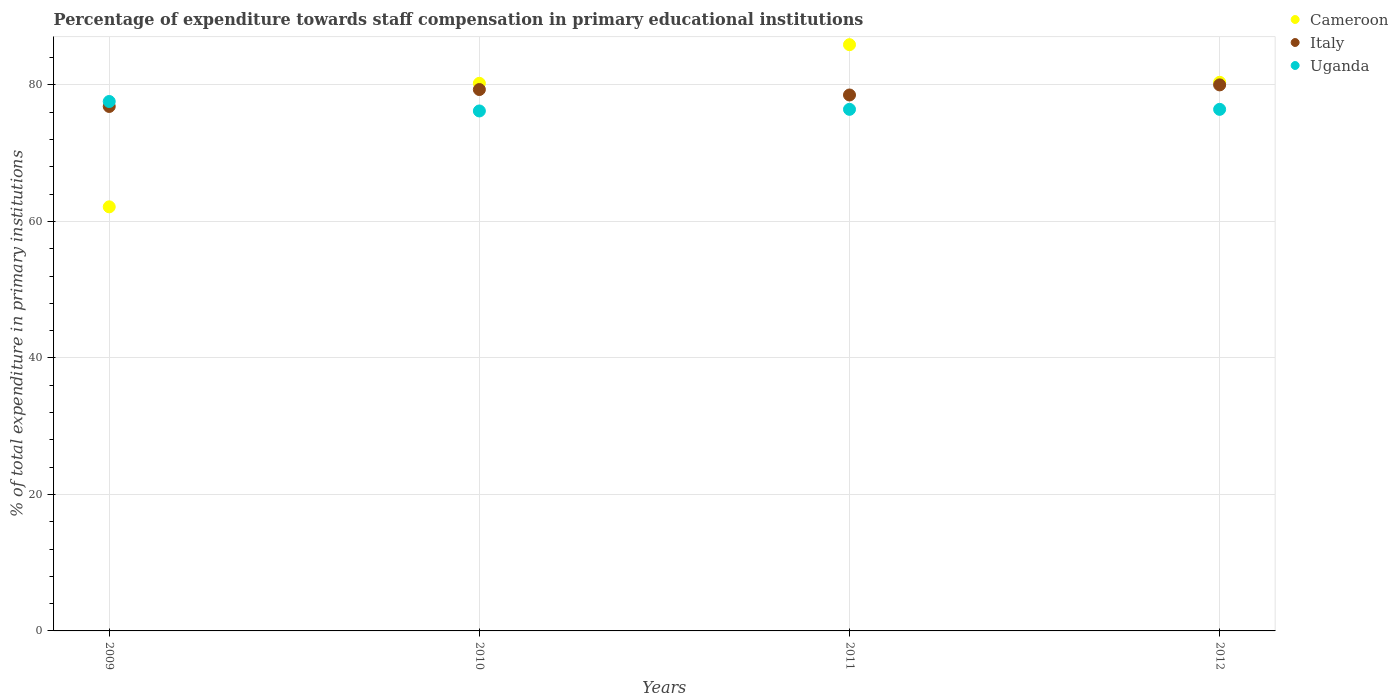How many different coloured dotlines are there?
Provide a succinct answer. 3. What is the percentage of expenditure towards staff compensation in Cameroon in 2012?
Your response must be concise. 80.4. Across all years, what is the maximum percentage of expenditure towards staff compensation in Italy?
Make the answer very short. 80.01. Across all years, what is the minimum percentage of expenditure towards staff compensation in Cameroon?
Offer a very short reply. 62.15. What is the total percentage of expenditure towards staff compensation in Cameroon in the graph?
Make the answer very short. 308.69. What is the difference between the percentage of expenditure towards staff compensation in Uganda in 2009 and that in 2011?
Offer a terse response. 1.15. What is the difference between the percentage of expenditure towards staff compensation in Uganda in 2011 and the percentage of expenditure towards staff compensation in Cameroon in 2012?
Provide a short and direct response. -3.96. What is the average percentage of expenditure towards staff compensation in Cameroon per year?
Offer a very short reply. 77.17. In the year 2010, what is the difference between the percentage of expenditure towards staff compensation in Cameroon and percentage of expenditure towards staff compensation in Uganda?
Provide a short and direct response. 4.05. What is the ratio of the percentage of expenditure towards staff compensation in Uganda in 2010 to that in 2011?
Give a very brief answer. 1. Is the difference between the percentage of expenditure towards staff compensation in Cameroon in 2009 and 2011 greater than the difference between the percentage of expenditure towards staff compensation in Uganda in 2009 and 2011?
Provide a succinct answer. No. What is the difference between the highest and the second highest percentage of expenditure towards staff compensation in Cameroon?
Make the answer very short. 5.51. What is the difference between the highest and the lowest percentage of expenditure towards staff compensation in Cameroon?
Offer a very short reply. 23.76. In how many years, is the percentage of expenditure towards staff compensation in Cameroon greater than the average percentage of expenditure towards staff compensation in Cameroon taken over all years?
Provide a succinct answer. 3. Is it the case that in every year, the sum of the percentage of expenditure towards staff compensation in Cameroon and percentage of expenditure towards staff compensation in Italy  is greater than the percentage of expenditure towards staff compensation in Uganda?
Offer a terse response. Yes. Does the percentage of expenditure towards staff compensation in Cameroon monotonically increase over the years?
Make the answer very short. No. Is the percentage of expenditure towards staff compensation in Uganda strictly greater than the percentage of expenditure towards staff compensation in Italy over the years?
Ensure brevity in your answer.  No. How many dotlines are there?
Offer a very short reply. 3. How many years are there in the graph?
Offer a very short reply. 4. What is the difference between two consecutive major ticks on the Y-axis?
Your answer should be compact. 20. Are the values on the major ticks of Y-axis written in scientific E-notation?
Your answer should be very brief. No. Does the graph contain grids?
Make the answer very short. Yes. Where does the legend appear in the graph?
Your response must be concise. Top right. How many legend labels are there?
Provide a short and direct response. 3. What is the title of the graph?
Your answer should be very brief. Percentage of expenditure towards staff compensation in primary educational institutions. What is the label or title of the X-axis?
Make the answer very short. Years. What is the label or title of the Y-axis?
Your response must be concise. % of total expenditure in primary institutions. What is the % of total expenditure in primary institutions of Cameroon in 2009?
Offer a very short reply. 62.15. What is the % of total expenditure in primary institutions in Italy in 2009?
Ensure brevity in your answer.  76.86. What is the % of total expenditure in primary institutions of Uganda in 2009?
Keep it short and to the point. 77.58. What is the % of total expenditure in primary institutions of Cameroon in 2010?
Make the answer very short. 80.25. What is the % of total expenditure in primary institutions in Italy in 2010?
Give a very brief answer. 79.33. What is the % of total expenditure in primary institutions of Uganda in 2010?
Your answer should be compact. 76.2. What is the % of total expenditure in primary institutions of Cameroon in 2011?
Keep it short and to the point. 85.91. What is the % of total expenditure in primary institutions in Italy in 2011?
Ensure brevity in your answer.  78.54. What is the % of total expenditure in primary institutions in Uganda in 2011?
Offer a terse response. 76.43. What is the % of total expenditure in primary institutions of Cameroon in 2012?
Provide a short and direct response. 80.4. What is the % of total expenditure in primary institutions of Italy in 2012?
Make the answer very short. 80.01. What is the % of total expenditure in primary institutions of Uganda in 2012?
Your response must be concise. 76.43. Across all years, what is the maximum % of total expenditure in primary institutions of Cameroon?
Offer a very short reply. 85.91. Across all years, what is the maximum % of total expenditure in primary institutions in Italy?
Your response must be concise. 80.01. Across all years, what is the maximum % of total expenditure in primary institutions in Uganda?
Offer a very short reply. 77.58. Across all years, what is the minimum % of total expenditure in primary institutions of Cameroon?
Provide a succinct answer. 62.15. Across all years, what is the minimum % of total expenditure in primary institutions in Italy?
Provide a succinct answer. 76.86. Across all years, what is the minimum % of total expenditure in primary institutions of Uganda?
Offer a terse response. 76.2. What is the total % of total expenditure in primary institutions in Cameroon in the graph?
Keep it short and to the point. 308.69. What is the total % of total expenditure in primary institutions in Italy in the graph?
Make the answer very short. 314.74. What is the total % of total expenditure in primary institutions in Uganda in the graph?
Make the answer very short. 306.64. What is the difference between the % of total expenditure in primary institutions in Cameroon in 2009 and that in 2010?
Your answer should be compact. -18.1. What is the difference between the % of total expenditure in primary institutions in Italy in 2009 and that in 2010?
Keep it short and to the point. -2.48. What is the difference between the % of total expenditure in primary institutions in Uganda in 2009 and that in 2010?
Your answer should be very brief. 1.39. What is the difference between the % of total expenditure in primary institutions in Cameroon in 2009 and that in 2011?
Give a very brief answer. -23.76. What is the difference between the % of total expenditure in primary institutions in Italy in 2009 and that in 2011?
Make the answer very short. -1.68. What is the difference between the % of total expenditure in primary institutions of Uganda in 2009 and that in 2011?
Your response must be concise. 1.15. What is the difference between the % of total expenditure in primary institutions in Cameroon in 2009 and that in 2012?
Offer a very short reply. -18.25. What is the difference between the % of total expenditure in primary institutions of Italy in 2009 and that in 2012?
Offer a very short reply. -3.16. What is the difference between the % of total expenditure in primary institutions in Uganda in 2009 and that in 2012?
Your response must be concise. 1.15. What is the difference between the % of total expenditure in primary institutions of Cameroon in 2010 and that in 2011?
Keep it short and to the point. -5.66. What is the difference between the % of total expenditure in primary institutions of Italy in 2010 and that in 2011?
Offer a terse response. 0.8. What is the difference between the % of total expenditure in primary institutions of Uganda in 2010 and that in 2011?
Your answer should be compact. -0.24. What is the difference between the % of total expenditure in primary institutions of Cameroon in 2010 and that in 2012?
Offer a very short reply. -0.15. What is the difference between the % of total expenditure in primary institutions in Italy in 2010 and that in 2012?
Make the answer very short. -0.68. What is the difference between the % of total expenditure in primary institutions of Uganda in 2010 and that in 2012?
Your answer should be very brief. -0.23. What is the difference between the % of total expenditure in primary institutions in Cameroon in 2011 and that in 2012?
Offer a terse response. 5.51. What is the difference between the % of total expenditure in primary institutions of Italy in 2011 and that in 2012?
Offer a terse response. -1.48. What is the difference between the % of total expenditure in primary institutions in Uganda in 2011 and that in 2012?
Provide a succinct answer. 0. What is the difference between the % of total expenditure in primary institutions of Cameroon in 2009 and the % of total expenditure in primary institutions of Italy in 2010?
Make the answer very short. -17.19. What is the difference between the % of total expenditure in primary institutions of Cameroon in 2009 and the % of total expenditure in primary institutions of Uganda in 2010?
Provide a succinct answer. -14.05. What is the difference between the % of total expenditure in primary institutions of Italy in 2009 and the % of total expenditure in primary institutions of Uganda in 2010?
Ensure brevity in your answer.  0.66. What is the difference between the % of total expenditure in primary institutions of Cameroon in 2009 and the % of total expenditure in primary institutions of Italy in 2011?
Keep it short and to the point. -16.39. What is the difference between the % of total expenditure in primary institutions of Cameroon in 2009 and the % of total expenditure in primary institutions of Uganda in 2011?
Give a very brief answer. -14.29. What is the difference between the % of total expenditure in primary institutions of Italy in 2009 and the % of total expenditure in primary institutions of Uganda in 2011?
Keep it short and to the point. 0.42. What is the difference between the % of total expenditure in primary institutions in Cameroon in 2009 and the % of total expenditure in primary institutions in Italy in 2012?
Provide a short and direct response. -17.87. What is the difference between the % of total expenditure in primary institutions in Cameroon in 2009 and the % of total expenditure in primary institutions in Uganda in 2012?
Ensure brevity in your answer.  -14.29. What is the difference between the % of total expenditure in primary institutions of Italy in 2009 and the % of total expenditure in primary institutions of Uganda in 2012?
Ensure brevity in your answer.  0.42. What is the difference between the % of total expenditure in primary institutions in Cameroon in 2010 and the % of total expenditure in primary institutions in Italy in 2011?
Make the answer very short. 1.71. What is the difference between the % of total expenditure in primary institutions of Cameroon in 2010 and the % of total expenditure in primary institutions of Uganda in 2011?
Make the answer very short. 3.81. What is the difference between the % of total expenditure in primary institutions in Italy in 2010 and the % of total expenditure in primary institutions in Uganda in 2011?
Keep it short and to the point. 2.9. What is the difference between the % of total expenditure in primary institutions of Cameroon in 2010 and the % of total expenditure in primary institutions of Italy in 2012?
Keep it short and to the point. 0.23. What is the difference between the % of total expenditure in primary institutions in Cameroon in 2010 and the % of total expenditure in primary institutions in Uganda in 2012?
Provide a short and direct response. 3.81. What is the difference between the % of total expenditure in primary institutions of Italy in 2010 and the % of total expenditure in primary institutions of Uganda in 2012?
Give a very brief answer. 2.9. What is the difference between the % of total expenditure in primary institutions in Cameroon in 2011 and the % of total expenditure in primary institutions in Italy in 2012?
Offer a very short reply. 5.89. What is the difference between the % of total expenditure in primary institutions of Cameroon in 2011 and the % of total expenditure in primary institutions of Uganda in 2012?
Offer a very short reply. 9.48. What is the difference between the % of total expenditure in primary institutions of Italy in 2011 and the % of total expenditure in primary institutions of Uganda in 2012?
Offer a terse response. 2.11. What is the average % of total expenditure in primary institutions in Cameroon per year?
Keep it short and to the point. 77.17. What is the average % of total expenditure in primary institutions of Italy per year?
Ensure brevity in your answer.  78.69. What is the average % of total expenditure in primary institutions of Uganda per year?
Your response must be concise. 76.66. In the year 2009, what is the difference between the % of total expenditure in primary institutions in Cameroon and % of total expenditure in primary institutions in Italy?
Give a very brief answer. -14.71. In the year 2009, what is the difference between the % of total expenditure in primary institutions of Cameroon and % of total expenditure in primary institutions of Uganda?
Provide a short and direct response. -15.44. In the year 2009, what is the difference between the % of total expenditure in primary institutions of Italy and % of total expenditure in primary institutions of Uganda?
Your response must be concise. -0.73. In the year 2010, what is the difference between the % of total expenditure in primary institutions in Cameroon and % of total expenditure in primary institutions in Italy?
Your response must be concise. 0.91. In the year 2010, what is the difference between the % of total expenditure in primary institutions in Cameroon and % of total expenditure in primary institutions in Uganda?
Give a very brief answer. 4.05. In the year 2010, what is the difference between the % of total expenditure in primary institutions in Italy and % of total expenditure in primary institutions in Uganda?
Your answer should be compact. 3.14. In the year 2011, what is the difference between the % of total expenditure in primary institutions of Cameroon and % of total expenditure in primary institutions of Italy?
Provide a short and direct response. 7.37. In the year 2011, what is the difference between the % of total expenditure in primary institutions of Cameroon and % of total expenditure in primary institutions of Uganda?
Provide a succinct answer. 9.48. In the year 2011, what is the difference between the % of total expenditure in primary institutions of Italy and % of total expenditure in primary institutions of Uganda?
Ensure brevity in your answer.  2.1. In the year 2012, what is the difference between the % of total expenditure in primary institutions in Cameroon and % of total expenditure in primary institutions in Italy?
Offer a very short reply. 0.38. In the year 2012, what is the difference between the % of total expenditure in primary institutions of Cameroon and % of total expenditure in primary institutions of Uganda?
Your answer should be very brief. 3.96. In the year 2012, what is the difference between the % of total expenditure in primary institutions of Italy and % of total expenditure in primary institutions of Uganda?
Provide a short and direct response. 3.58. What is the ratio of the % of total expenditure in primary institutions of Cameroon in 2009 to that in 2010?
Make the answer very short. 0.77. What is the ratio of the % of total expenditure in primary institutions of Italy in 2009 to that in 2010?
Your response must be concise. 0.97. What is the ratio of the % of total expenditure in primary institutions in Uganda in 2009 to that in 2010?
Give a very brief answer. 1.02. What is the ratio of the % of total expenditure in primary institutions of Cameroon in 2009 to that in 2011?
Ensure brevity in your answer.  0.72. What is the ratio of the % of total expenditure in primary institutions in Italy in 2009 to that in 2011?
Make the answer very short. 0.98. What is the ratio of the % of total expenditure in primary institutions in Uganda in 2009 to that in 2011?
Your response must be concise. 1.02. What is the ratio of the % of total expenditure in primary institutions in Cameroon in 2009 to that in 2012?
Provide a succinct answer. 0.77. What is the ratio of the % of total expenditure in primary institutions in Italy in 2009 to that in 2012?
Keep it short and to the point. 0.96. What is the ratio of the % of total expenditure in primary institutions of Uganda in 2009 to that in 2012?
Give a very brief answer. 1.02. What is the ratio of the % of total expenditure in primary institutions in Cameroon in 2010 to that in 2011?
Make the answer very short. 0.93. What is the ratio of the % of total expenditure in primary institutions in Italy in 2010 to that in 2011?
Give a very brief answer. 1.01. What is the ratio of the % of total expenditure in primary institutions of Cameroon in 2010 to that in 2012?
Offer a terse response. 1. What is the ratio of the % of total expenditure in primary institutions of Cameroon in 2011 to that in 2012?
Give a very brief answer. 1.07. What is the ratio of the % of total expenditure in primary institutions of Italy in 2011 to that in 2012?
Provide a short and direct response. 0.98. What is the ratio of the % of total expenditure in primary institutions in Uganda in 2011 to that in 2012?
Give a very brief answer. 1. What is the difference between the highest and the second highest % of total expenditure in primary institutions of Cameroon?
Provide a short and direct response. 5.51. What is the difference between the highest and the second highest % of total expenditure in primary institutions in Italy?
Provide a succinct answer. 0.68. What is the difference between the highest and the second highest % of total expenditure in primary institutions of Uganda?
Your answer should be very brief. 1.15. What is the difference between the highest and the lowest % of total expenditure in primary institutions in Cameroon?
Ensure brevity in your answer.  23.76. What is the difference between the highest and the lowest % of total expenditure in primary institutions in Italy?
Make the answer very short. 3.16. What is the difference between the highest and the lowest % of total expenditure in primary institutions of Uganda?
Offer a very short reply. 1.39. 